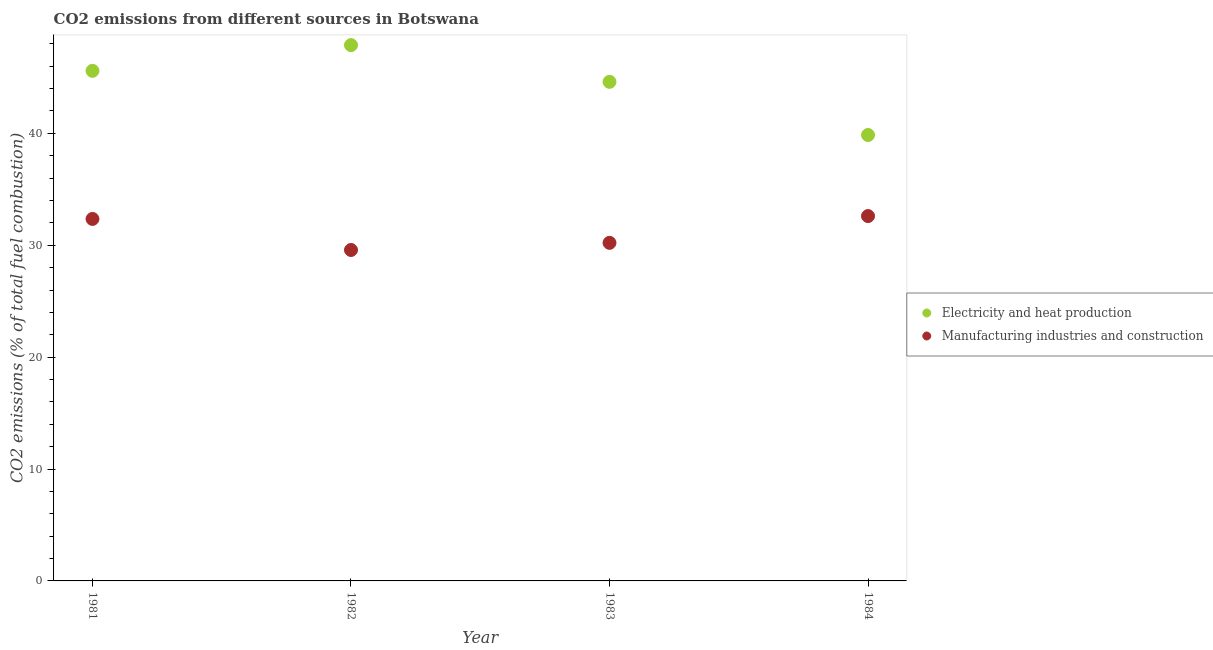What is the co2 emissions due to manufacturing industries in 1983?
Your answer should be very brief. 30.22. Across all years, what is the maximum co2 emissions due to manufacturing industries?
Your answer should be very brief. 32.61. Across all years, what is the minimum co2 emissions due to manufacturing industries?
Your answer should be very brief. 29.58. What is the total co2 emissions due to manufacturing industries in the graph?
Your answer should be very brief. 124.75. What is the difference between the co2 emissions due to electricity and heat production in 1981 and that in 1983?
Your answer should be very brief. 0.98. What is the difference between the co2 emissions due to electricity and heat production in 1981 and the co2 emissions due to manufacturing industries in 1983?
Offer a very short reply. 15.37. What is the average co2 emissions due to manufacturing industries per year?
Offer a very short reply. 31.19. In the year 1983, what is the difference between the co2 emissions due to electricity and heat production and co2 emissions due to manufacturing industries?
Provide a short and direct response. 14.39. What is the ratio of the co2 emissions due to manufacturing industries in 1981 to that in 1983?
Offer a terse response. 1.07. What is the difference between the highest and the second highest co2 emissions due to electricity and heat production?
Your response must be concise. 2.3. What is the difference between the highest and the lowest co2 emissions due to electricity and heat production?
Make the answer very short. 8.03. Is the co2 emissions due to electricity and heat production strictly greater than the co2 emissions due to manufacturing industries over the years?
Offer a terse response. Yes. Does the graph contain grids?
Your answer should be compact. No. Where does the legend appear in the graph?
Your answer should be very brief. Center right. How many legend labels are there?
Provide a succinct answer. 2. What is the title of the graph?
Keep it short and to the point. CO2 emissions from different sources in Botswana. What is the label or title of the X-axis?
Your answer should be very brief. Year. What is the label or title of the Y-axis?
Provide a succinct answer. CO2 emissions (% of total fuel combustion). What is the CO2 emissions (% of total fuel combustion) in Electricity and heat production in 1981?
Make the answer very short. 45.59. What is the CO2 emissions (% of total fuel combustion) of Manufacturing industries and construction in 1981?
Your answer should be very brief. 32.35. What is the CO2 emissions (% of total fuel combustion) in Electricity and heat production in 1982?
Offer a terse response. 47.89. What is the CO2 emissions (% of total fuel combustion) in Manufacturing industries and construction in 1982?
Offer a terse response. 29.58. What is the CO2 emissions (% of total fuel combustion) of Electricity and heat production in 1983?
Give a very brief answer. 44.6. What is the CO2 emissions (% of total fuel combustion) in Manufacturing industries and construction in 1983?
Provide a short and direct response. 30.22. What is the CO2 emissions (% of total fuel combustion) in Electricity and heat production in 1984?
Make the answer very short. 39.86. What is the CO2 emissions (% of total fuel combustion) of Manufacturing industries and construction in 1984?
Provide a short and direct response. 32.61. Across all years, what is the maximum CO2 emissions (% of total fuel combustion) in Electricity and heat production?
Your response must be concise. 47.89. Across all years, what is the maximum CO2 emissions (% of total fuel combustion) of Manufacturing industries and construction?
Your answer should be very brief. 32.61. Across all years, what is the minimum CO2 emissions (% of total fuel combustion) in Electricity and heat production?
Provide a short and direct response. 39.86. Across all years, what is the minimum CO2 emissions (% of total fuel combustion) of Manufacturing industries and construction?
Your answer should be compact. 29.58. What is the total CO2 emissions (% of total fuel combustion) in Electricity and heat production in the graph?
Keep it short and to the point. 177.93. What is the total CO2 emissions (% of total fuel combustion) in Manufacturing industries and construction in the graph?
Give a very brief answer. 124.75. What is the difference between the CO2 emissions (% of total fuel combustion) in Electricity and heat production in 1981 and that in 1982?
Keep it short and to the point. -2.3. What is the difference between the CO2 emissions (% of total fuel combustion) of Manufacturing industries and construction in 1981 and that in 1982?
Ensure brevity in your answer.  2.78. What is the difference between the CO2 emissions (% of total fuel combustion) in Electricity and heat production in 1981 and that in 1983?
Your answer should be compact. 0.98. What is the difference between the CO2 emissions (% of total fuel combustion) in Manufacturing industries and construction in 1981 and that in 1983?
Your answer should be very brief. 2.14. What is the difference between the CO2 emissions (% of total fuel combustion) in Electricity and heat production in 1981 and that in 1984?
Ensure brevity in your answer.  5.73. What is the difference between the CO2 emissions (% of total fuel combustion) of Manufacturing industries and construction in 1981 and that in 1984?
Offer a very short reply. -0.26. What is the difference between the CO2 emissions (% of total fuel combustion) in Electricity and heat production in 1982 and that in 1983?
Provide a succinct answer. 3.28. What is the difference between the CO2 emissions (% of total fuel combustion) in Manufacturing industries and construction in 1982 and that in 1983?
Your answer should be very brief. -0.64. What is the difference between the CO2 emissions (% of total fuel combustion) of Electricity and heat production in 1982 and that in 1984?
Keep it short and to the point. 8.03. What is the difference between the CO2 emissions (% of total fuel combustion) in Manufacturing industries and construction in 1982 and that in 1984?
Provide a short and direct response. -3.03. What is the difference between the CO2 emissions (% of total fuel combustion) of Electricity and heat production in 1983 and that in 1984?
Your response must be concise. 4.75. What is the difference between the CO2 emissions (% of total fuel combustion) in Manufacturing industries and construction in 1983 and that in 1984?
Ensure brevity in your answer.  -2.39. What is the difference between the CO2 emissions (% of total fuel combustion) of Electricity and heat production in 1981 and the CO2 emissions (% of total fuel combustion) of Manufacturing industries and construction in 1982?
Keep it short and to the point. 16.01. What is the difference between the CO2 emissions (% of total fuel combustion) of Electricity and heat production in 1981 and the CO2 emissions (% of total fuel combustion) of Manufacturing industries and construction in 1983?
Your response must be concise. 15.37. What is the difference between the CO2 emissions (% of total fuel combustion) in Electricity and heat production in 1981 and the CO2 emissions (% of total fuel combustion) in Manufacturing industries and construction in 1984?
Your answer should be very brief. 12.98. What is the difference between the CO2 emissions (% of total fuel combustion) in Electricity and heat production in 1982 and the CO2 emissions (% of total fuel combustion) in Manufacturing industries and construction in 1983?
Your response must be concise. 17.67. What is the difference between the CO2 emissions (% of total fuel combustion) in Electricity and heat production in 1982 and the CO2 emissions (% of total fuel combustion) in Manufacturing industries and construction in 1984?
Ensure brevity in your answer.  15.28. What is the difference between the CO2 emissions (% of total fuel combustion) of Electricity and heat production in 1983 and the CO2 emissions (% of total fuel combustion) of Manufacturing industries and construction in 1984?
Your answer should be very brief. 12. What is the average CO2 emissions (% of total fuel combustion) of Electricity and heat production per year?
Offer a terse response. 44.48. What is the average CO2 emissions (% of total fuel combustion) in Manufacturing industries and construction per year?
Keep it short and to the point. 31.19. In the year 1981, what is the difference between the CO2 emissions (% of total fuel combustion) in Electricity and heat production and CO2 emissions (% of total fuel combustion) in Manufacturing industries and construction?
Offer a very short reply. 13.24. In the year 1982, what is the difference between the CO2 emissions (% of total fuel combustion) of Electricity and heat production and CO2 emissions (% of total fuel combustion) of Manufacturing industries and construction?
Your answer should be very brief. 18.31. In the year 1983, what is the difference between the CO2 emissions (% of total fuel combustion) in Electricity and heat production and CO2 emissions (% of total fuel combustion) in Manufacturing industries and construction?
Your answer should be compact. 14.39. In the year 1984, what is the difference between the CO2 emissions (% of total fuel combustion) in Electricity and heat production and CO2 emissions (% of total fuel combustion) in Manufacturing industries and construction?
Ensure brevity in your answer.  7.25. What is the ratio of the CO2 emissions (% of total fuel combustion) of Manufacturing industries and construction in 1981 to that in 1982?
Offer a very short reply. 1.09. What is the ratio of the CO2 emissions (% of total fuel combustion) of Electricity and heat production in 1981 to that in 1983?
Ensure brevity in your answer.  1.02. What is the ratio of the CO2 emissions (% of total fuel combustion) of Manufacturing industries and construction in 1981 to that in 1983?
Provide a short and direct response. 1.07. What is the ratio of the CO2 emissions (% of total fuel combustion) of Electricity and heat production in 1981 to that in 1984?
Your answer should be very brief. 1.14. What is the ratio of the CO2 emissions (% of total fuel combustion) in Manufacturing industries and construction in 1981 to that in 1984?
Offer a terse response. 0.99. What is the ratio of the CO2 emissions (% of total fuel combustion) of Electricity and heat production in 1982 to that in 1983?
Offer a very short reply. 1.07. What is the ratio of the CO2 emissions (% of total fuel combustion) in Manufacturing industries and construction in 1982 to that in 1983?
Your response must be concise. 0.98. What is the ratio of the CO2 emissions (% of total fuel combustion) of Electricity and heat production in 1982 to that in 1984?
Ensure brevity in your answer.  1.2. What is the ratio of the CO2 emissions (% of total fuel combustion) in Manufacturing industries and construction in 1982 to that in 1984?
Provide a short and direct response. 0.91. What is the ratio of the CO2 emissions (% of total fuel combustion) of Electricity and heat production in 1983 to that in 1984?
Your answer should be very brief. 1.12. What is the ratio of the CO2 emissions (% of total fuel combustion) in Manufacturing industries and construction in 1983 to that in 1984?
Give a very brief answer. 0.93. What is the difference between the highest and the second highest CO2 emissions (% of total fuel combustion) of Electricity and heat production?
Keep it short and to the point. 2.3. What is the difference between the highest and the second highest CO2 emissions (% of total fuel combustion) in Manufacturing industries and construction?
Keep it short and to the point. 0.26. What is the difference between the highest and the lowest CO2 emissions (% of total fuel combustion) in Electricity and heat production?
Give a very brief answer. 8.03. What is the difference between the highest and the lowest CO2 emissions (% of total fuel combustion) of Manufacturing industries and construction?
Make the answer very short. 3.03. 